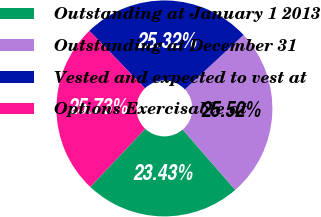Convert chart to OTSL. <chart><loc_0><loc_0><loc_500><loc_500><pie_chart><fcel>Outstanding at January 1 2013<fcel>Outstanding at December 31<fcel>Vested and expected to vest at<fcel>Options Exercisable at<nl><fcel>23.43%<fcel>25.52%<fcel>25.32%<fcel>25.73%<nl></chart> 